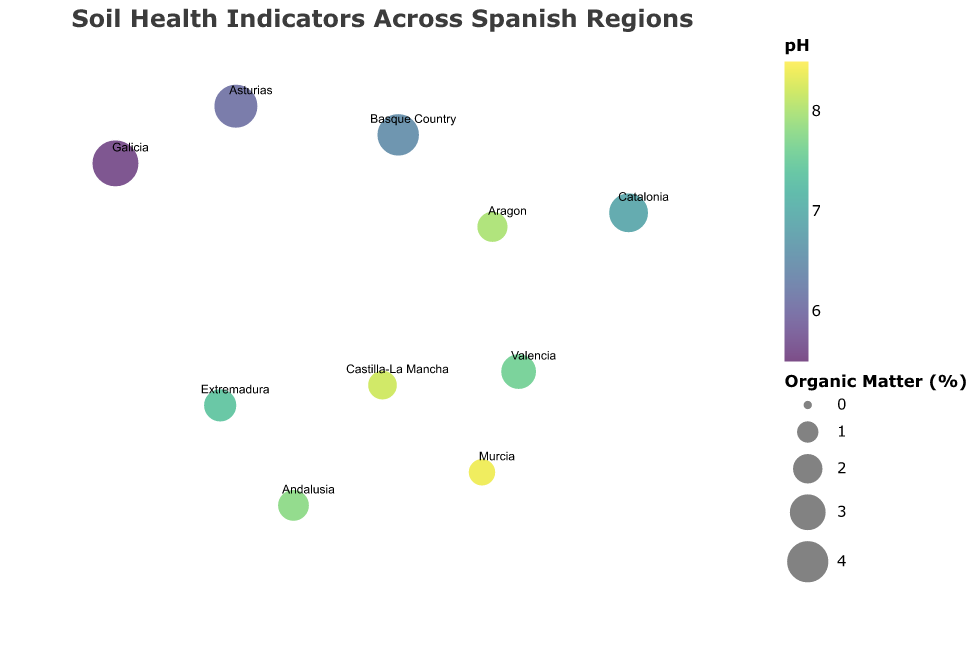What is the region with the highest infiltration rate? The infiltration rate for each region is indicated by the tooltip in the figure. By comparing these values, we find that Galicia has the highest rate.
Answer: Galicia Which region has the lowest microbial biomass? The tooltip in the figure provides microbial biomass values for each region. Comparing these values, Murcia has the lowest microbial biomass of 150 mg/kg.
Answer: Murcia What is the average organic matter percentage across all listed regions? Sum the organic matter percentages for all regions: 2.1 + 3.4 + 4.8 + 1.8 + 3.9 + 2.3 + 2.7 + 2.0 + 4.2 + 1.5 = 28.7. Then divide by the number of regions (10): 28.7 / 10 = 2.87.
Answer: 2.87% Which regions have a pH less than 7? According to the tooltip values, the regions with a pH less than 7 are Catalonia, Galicia, and the Basque Country.
Answer: Catalonia, Galicia, Basque Country Compare the earthworm count between Andalusia and Galicia. Which has more? The tooltip indicates that Andalusia has 18 earthworms per square meter, whereas Galicia has 45. Therefore, Galicia has more earthworms.
Answer: Galicia What is the median infiltration rate for all the regions? List the infiltration rates in ascending order: 7, 10, 13, 15, 18, 22, 28, 32, 35, 40. The median value (middle value in an ordered list) is the average of the 5th and 6th values: (18 + 22) / 2 = 20.
Answer: 20 mm/hr How does the microbial biomass in Asturias compare to that in Murcia? The tooltip shows Asturias with a microbial biomass of 380 mg/kg and Murcia with 150 mg/kg. Asturias has more microbial biomass.
Answer: Asturias Which region has the highest organic matter content? The tooltip indicates the organic matter percentage for each region. Galicia has the highest organic matter at 4.8%.
Answer: Galicia Are there any regions with a pH over 8.0? According to the tooltip, Castilla-La Mancha and Murcia have a pH over 8.0.
Answer: Castilla-La Mancha, Murcia Which regions have both high organic matter and high microbial biomass? High organic matter and microbial biomass can be considered above the median value for these indicators. Galicia and Asturias both have high levels in both categories.
Answer: Galicia, Asturias 